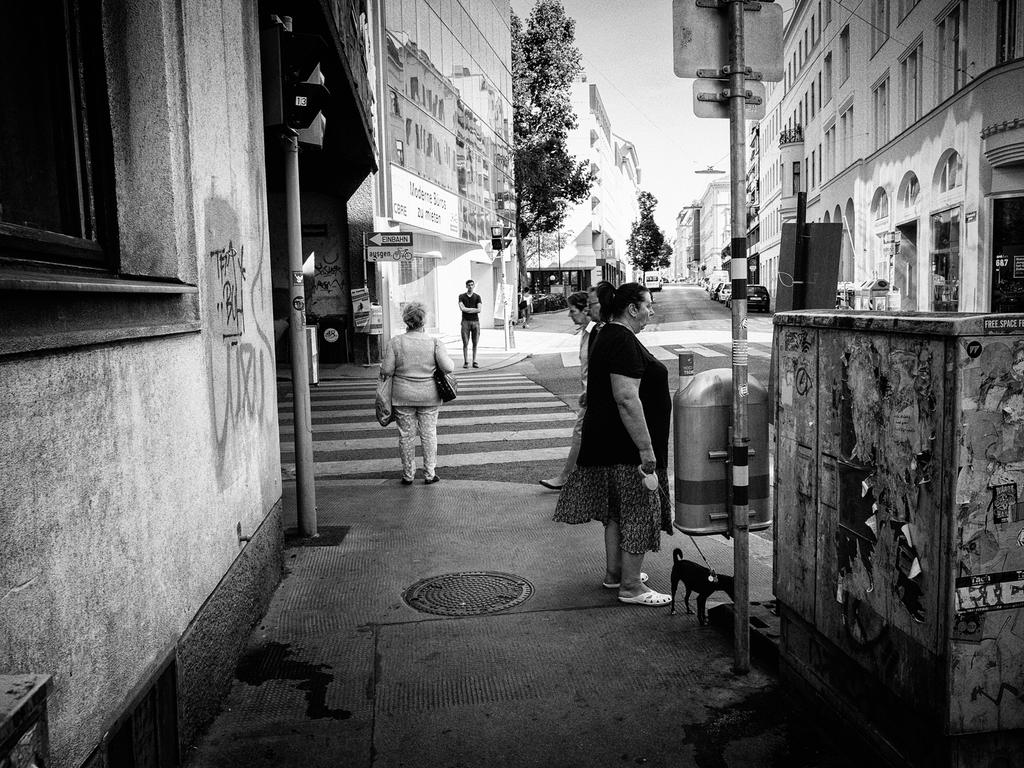What is the color scheme of the image? The image is black and white. What type of scene is depicted in the image? It is a street view. What can be seen on the left side of the image? There are trees and buildings on the left side of the image. What can be seen on the right side of the image? There are trees and buildings on the right side of the image. How many people are walking on the road in the image? There are four people walking on the road in the image. What is the caption of the image? There is no caption present in the image. What type of noise can be heard coming from the buildings in the image? There is no sound or noise present in the image, as it is a still photograph. 